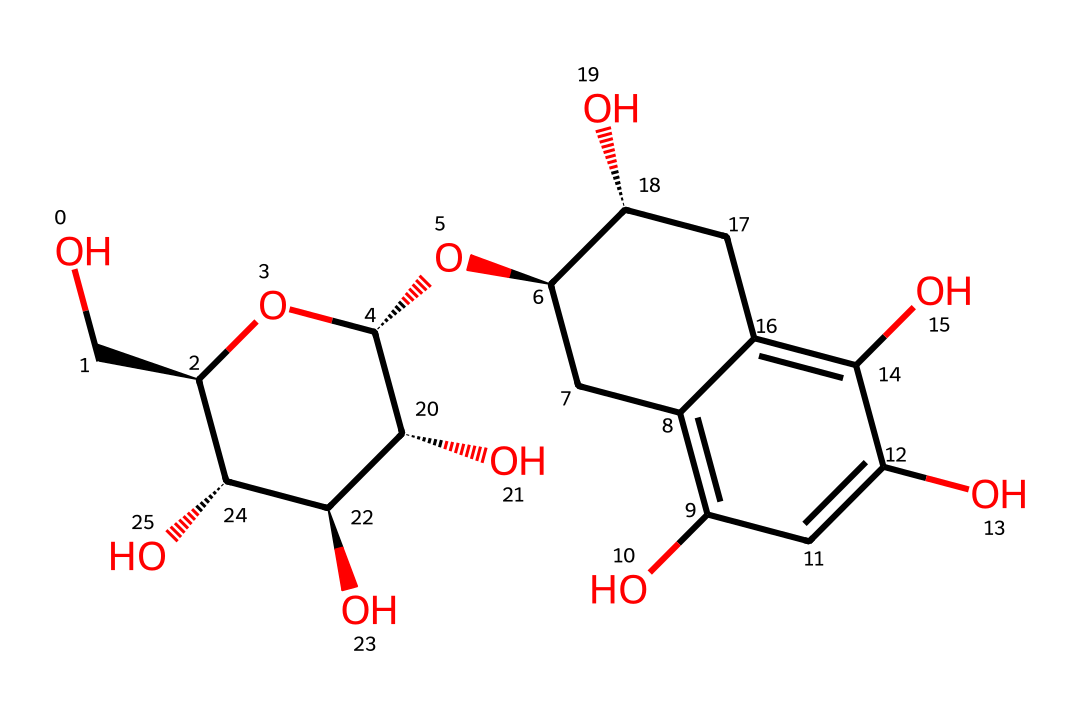What is the molecular formula of (+)-catechin? To determine the molecular formula, count the number of each type of atom present in the chemical structure. On analyzing the structure, there are 15 carbon atoms, 14 hydrogen atoms, and 6 oxygen atoms. Thus, the molecular formula is C15H14O6.
Answer: C15H14O6 How many stereocenters are present in (+)-catechin? A stereocenter is typically a carbon atom attached to four different substituents. In the structure, there are four carbon atoms that fit this criterion, meaning there are four stereocenters.
Answer: 4 What functional groups can be identified in (+)-catechin? By examining the structure, we can identify several functional groups such as hydroxyl (-OH) groups, which appear multiple times. These contribute to its properties as a flavonoid.
Answer: hydroxyl What is the role of chirality in (+)-catechin? Chirality influences how a molecule interacts with other chiral environments, such as enzymes or receptors. For (+)-catechin, its chiral centers allow it to have distinct biochemical activities compared to its mirror image.
Answer: biochemical activity Which type of chemical is (+)-catechin classified as? The structure reveals that (+)-catechin contains polyphenolic compounds known for their antioxidant properties, identifying it as a flavonoid, specifically a flavan-3-ol.
Answer: flavonoid How many rings are present in the structure of (+)-catechin? Analyzing the structure, one can see two benzene-like rings (aromatic rings), indicating the presence of two rings in the molecular structure.
Answer: 2 What type of chirality does (+)-catechin exhibit? The specific configuration of the stereocenters in (+)-catechin is designated as S for some and R for others, making it a compound with multiple chiral centers resulting in specific stereoisomerism.
Answer: stereoisomerism 